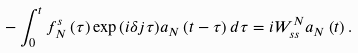Convert formula to latex. <formula><loc_0><loc_0><loc_500><loc_500>- \int _ { 0 } ^ { t } f ^ { s } _ { N } \left ( \tau \right ) \exp { \left ( i \delta j \tau \right ) } a _ { N } \left ( t - \tau \right ) d \tau = i W ^ { N } _ { s s } a _ { N } \left ( t \right ) .</formula> 